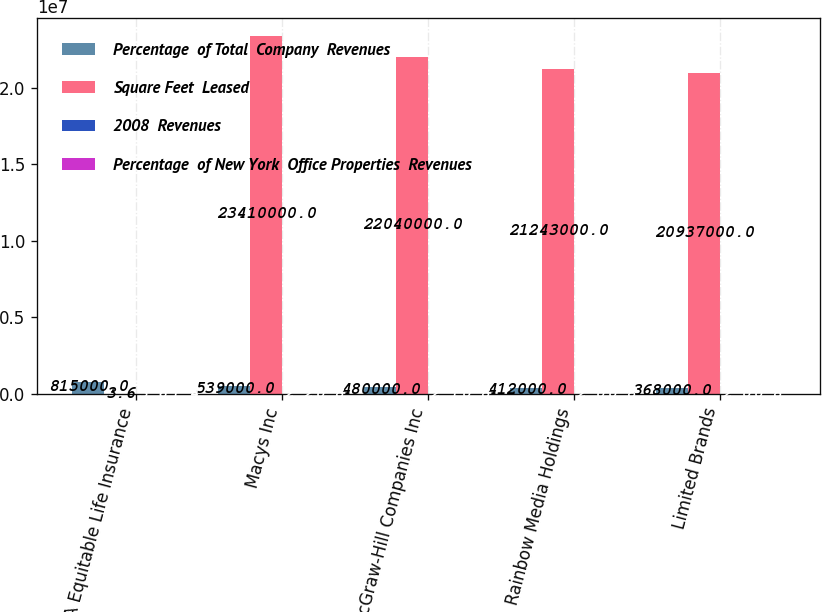Convert chart. <chart><loc_0><loc_0><loc_500><loc_500><stacked_bar_chart><ecel><fcel>AXA Equitable Life Insurance<fcel>Macys Inc<fcel>McGraw-Hill Companies Inc<fcel>Rainbow Media Holdings<fcel>Limited Brands<nl><fcel>Percentage  of Total  Company  Revenues<fcel>815000<fcel>539000<fcel>480000<fcel>412000<fcel>368000<nl><fcel>Square Feet  Leased<fcel>3.6<fcel>2.341e+07<fcel>2.204e+07<fcel>2.1243e+07<fcel>2.0937e+07<nl><fcel>2008  Revenues<fcel>3.6<fcel>2.2<fcel>2.1<fcel>2<fcel>2<nl><fcel>Percentage  of New York  Office Properties  Revenues<fcel>1.4<fcel>0.8<fcel>0.8<fcel>0.8<fcel>0.8<nl></chart> 